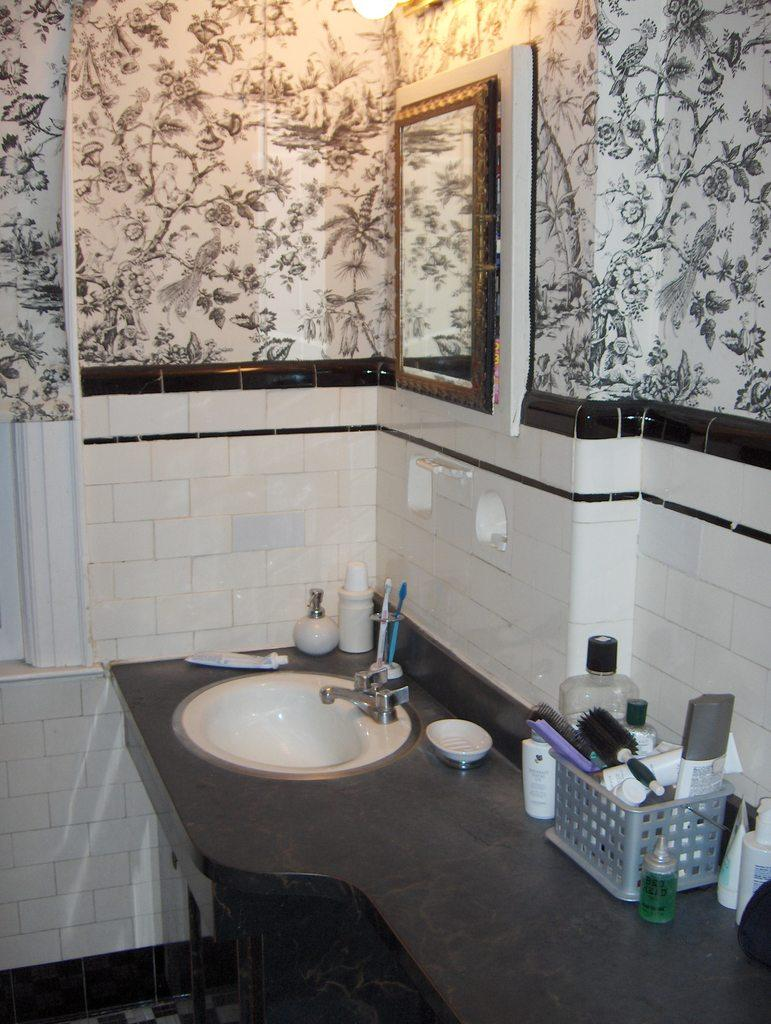What is the main fixture in the image? There is a sink in the image. What is attached to the sink? There is a tap in the image. What items are used for cleaning or grooming in the image? There are brushes, combs, and toothpaste in the image. What is used for holding or storing items in the image? There is a basket in the image. What is used for containing liquids in the image? There are bottles in the image. What is used for reflecting or checking appearance in the image? There is a mirror in the image. What is the wall surface made of in the image? The wall has tiles in the image. What type of nail is being hammered into the wall in the image? There is no nail being hammered into the wall in the image. What event is taking place in the image? The image does not depict an event; it shows a sink and related items. 